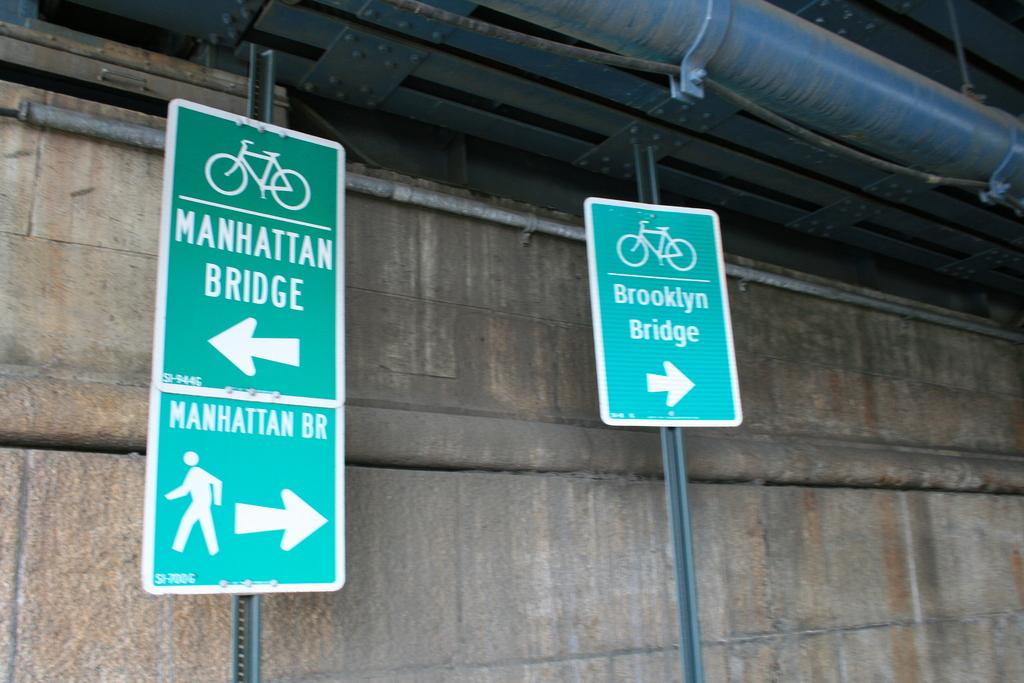What bridge is to the right?
Offer a very short reply. Brooklyn bridge. 